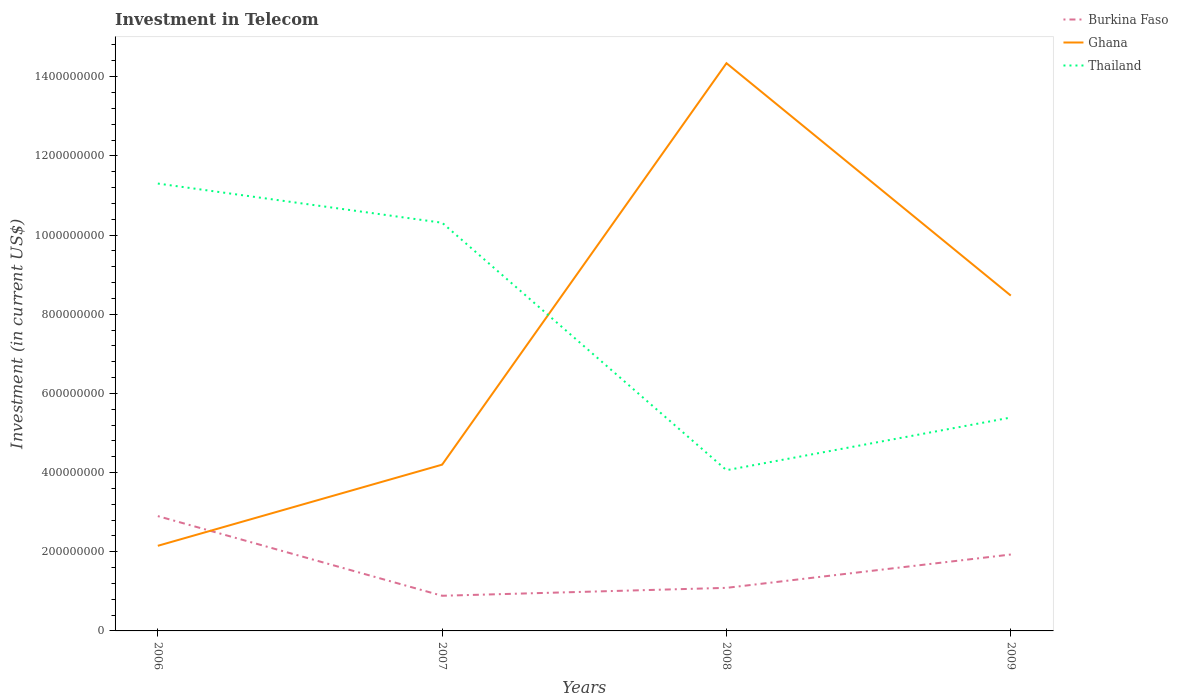How many different coloured lines are there?
Provide a succinct answer. 3. Across all years, what is the maximum amount invested in telecom in Burkina Faso?
Ensure brevity in your answer.  8.88e+07. What is the total amount invested in telecom in Ghana in the graph?
Your answer should be compact. -4.27e+08. What is the difference between the highest and the second highest amount invested in telecom in Ghana?
Keep it short and to the point. 1.22e+09. What is the difference between the highest and the lowest amount invested in telecom in Thailand?
Offer a terse response. 2. Is the amount invested in telecom in Burkina Faso strictly greater than the amount invested in telecom in Ghana over the years?
Give a very brief answer. No. How many lines are there?
Give a very brief answer. 3. What is the difference between two consecutive major ticks on the Y-axis?
Give a very brief answer. 2.00e+08. Are the values on the major ticks of Y-axis written in scientific E-notation?
Keep it short and to the point. No. Where does the legend appear in the graph?
Offer a very short reply. Top right. What is the title of the graph?
Keep it short and to the point. Investment in Telecom. What is the label or title of the Y-axis?
Your answer should be compact. Investment (in current US$). What is the Investment (in current US$) of Burkina Faso in 2006?
Your response must be concise. 2.90e+08. What is the Investment (in current US$) in Ghana in 2006?
Your answer should be very brief. 2.15e+08. What is the Investment (in current US$) in Thailand in 2006?
Offer a terse response. 1.13e+09. What is the Investment (in current US$) in Burkina Faso in 2007?
Make the answer very short. 8.88e+07. What is the Investment (in current US$) of Ghana in 2007?
Provide a succinct answer. 4.20e+08. What is the Investment (in current US$) of Thailand in 2007?
Your answer should be compact. 1.03e+09. What is the Investment (in current US$) in Burkina Faso in 2008?
Your response must be concise. 1.09e+08. What is the Investment (in current US$) in Ghana in 2008?
Provide a succinct answer. 1.43e+09. What is the Investment (in current US$) of Thailand in 2008?
Make the answer very short. 4.06e+08. What is the Investment (in current US$) of Burkina Faso in 2009?
Provide a succinct answer. 1.93e+08. What is the Investment (in current US$) in Ghana in 2009?
Provide a short and direct response. 8.47e+08. What is the Investment (in current US$) of Thailand in 2009?
Keep it short and to the point. 5.39e+08. Across all years, what is the maximum Investment (in current US$) in Burkina Faso?
Offer a terse response. 2.90e+08. Across all years, what is the maximum Investment (in current US$) in Ghana?
Provide a succinct answer. 1.43e+09. Across all years, what is the maximum Investment (in current US$) in Thailand?
Your response must be concise. 1.13e+09. Across all years, what is the minimum Investment (in current US$) in Burkina Faso?
Offer a very short reply. 8.88e+07. Across all years, what is the minimum Investment (in current US$) in Ghana?
Ensure brevity in your answer.  2.15e+08. Across all years, what is the minimum Investment (in current US$) in Thailand?
Your response must be concise. 4.06e+08. What is the total Investment (in current US$) of Burkina Faso in the graph?
Keep it short and to the point. 6.81e+08. What is the total Investment (in current US$) of Ghana in the graph?
Keep it short and to the point. 2.92e+09. What is the total Investment (in current US$) of Thailand in the graph?
Make the answer very short. 3.11e+09. What is the difference between the Investment (in current US$) of Burkina Faso in 2006 and that in 2007?
Offer a terse response. 2.01e+08. What is the difference between the Investment (in current US$) in Ghana in 2006 and that in 2007?
Your answer should be very brief. -2.05e+08. What is the difference between the Investment (in current US$) in Thailand in 2006 and that in 2007?
Make the answer very short. 9.90e+07. What is the difference between the Investment (in current US$) in Burkina Faso in 2006 and that in 2008?
Make the answer very short. 1.81e+08. What is the difference between the Investment (in current US$) in Ghana in 2006 and that in 2008?
Your answer should be compact. -1.22e+09. What is the difference between the Investment (in current US$) in Thailand in 2006 and that in 2008?
Your response must be concise. 7.24e+08. What is the difference between the Investment (in current US$) of Burkina Faso in 2006 and that in 2009?
Offer a terse response. 9.70e+07. What is the difference between the Investment (in current US$) of Ghana in 2006 and that in 2009?
Provide a short and direct response. -6.32e+08. What is the difference between the Investment (in current US$) of Thailand in 2006 and that in 2009?
Your answer should be very brief. 5.91e+08. What is the difference between the Investment (in current US$) in Burkina Faso in 2007 and that in 2008?
Your answer should be compact. -2.00e+07. What is the difference between the Investment (in current US$) in Ghana in 2007 and that in 2008?
Your answer should be compact. -1.01e+09. What is the difference between the Investment (in current US$) of Thailand in 2007 and that in 2008?
Your response must be concise. 6.25e+08. What is the difference between the Investment (in current US$) in Burkina Faso in 2007 and that in 2009?
Your answer should be very brief. -1.04e+08. What is the difference between the Investment (in current US$) in Ghana in 2007 and that in 2009?
Provide a short and direct response. -4.27e+08. What is the difference between the Investment (in current US$) in Thailand in 2007 and that in 2009?
Your answer should be very brief. 4.92e+08. What is the difference between the Investment (in current US$) in Burkina Faso in 2008 and that in 2009?
Give a very brief answer. -8.42e+07. What is the difference between the Investment (in current US$) in Ghana in 2008 and that in 2009?
Keep it short and to the point. 5.87e+08. What is the difference between the Investment (in current US$) of Thailand in 2008 and that in 2009?
Your answer should be compact. -1.33e+08. What is the difference between the Investment (in current US$) of Burkina Faso in 2006 and the Investment (in current US$) of Ghana in 2007?
Your answer should be very brief. -1.30e+08. What is the difference between the Investment (in current US$) in Burkina Faso in 2006 and the Investment (in current US$) in Thailand in 2007?
Provide a short and direct response. -7.41e+08. What is the difference between the Investment (in current US$) in Ghana in 2006 and the Investment (in current US$) in Thailand in 2007?
Offer a very short reply. -8.16e+08. What is the difference between the Investment (in current US$) in Burkina Faso in 2006 and the Investment (in current US$) in Ghana in 2008?
Provide a succinct answer. -1.14e+09. What is the difference between the Investment (in current US$) in Burkina Faso in 2006 and the Investment (in current US$) in Thailand in 2008?
Keep it short and to the point. -1.16e+08. What is the difference between the Investment (in current US$) of Ghana in 2006 and the Investment (in current US$) of Thailand in 2008?
Your answer should be very brief. -1.91e+08. What is the difference between the Investment (in current US$) in Burkina Faso in 2006 and the Investment (in current US$) in Ghana in 2009?
Your answer should be compact. -5.57e+08. What is the difference between the Investment (in current US$) in Burkina Faso in 2006 and the Investment (in current US$) in Thailand in 2009?
Keep it short and to the point. -2.49e+08. What is the difference between the Investment (in current US$) in Ghana in 2006 and the Investment (in current US$) in Thailand in 2009?
Ensure brevity in your answer.  -3.24e+08. What is the difference between the Investment (in current US$) of Burkina Faso in 2007 and the Investment (in current US$) of Ghana in 2008?
Your response must be concise. -1.35e+09. What is the difference between the Investment (in current US$) of Burkina Faso in 2007 and the Investment (in current US$) of Thailand in 2008?
Offer a terse response. -3.17e+08. What is the difference between the Investment (in current US$) of Ghana in 2007 and the Investment (in current US$) of Thailand in 2008?
Offer a very short reply. 1.40e+07. What is the difference between the Investment (in current US$) in Burkina Faso in 2007 and the Investment (in current US$) in Ghana in 2009?
Your answer should be very brief. -7.58e+08. What is the difference between the Investment (in current US$) of Burkina Faso in 2007 and the Investment (in current US$) of Thailand in 2009?
Provide a short and direct response. -4.50e+08. What is the difference between the Investment (in current US$) of Ghana in 2007 and the Investment (in current US$) of Thailand in 2009?
Offer a very short reply. -1.19e+08. What is the difference between the Investment (in current US$) of Burkina Faso in 2008 and the Investment (in current US$) of Ghana in 2009?
Offer a very short reply. -7.38e+08. What is the difference between the Investment (in current US$) of Burkina Faso in 2008 and the Investment (in current US$) of Thailand in 2009?
Make the answer very short. -4.30e+08. What is the difference between the Investment (in current US$) in Ghana in 2008 and the Investment (in current US$) in Thailand in 2009?
Keep it short and to the point. 8.95e+08. What is the average Investment (in current US$) in Burkina Faso per year?
Your response must be concise. 1.70e+08. What is the average Investment (in current US$) of Ghana per year?
Ensure brevity in your answer.  7.29e+08. What is the average Investment (in current US$) of Thailand per year?
Offer a terse response. 7.76e+08. In the year 2006, what is the difference between the Investment (in current US$) of Burkina Faso and Investment (in current US$) of Ghana?
Make the answer very short. 7.50e+07. In the year 2006, what is the difference between the Investment (in current US$) in Burkina Faso and Investment (in current US$) in Thailand?
Offer a terse response. -8.40e+08. In the year 2006, what is the difference between the Investment (in current US$) in Ghana and Investment (in current US$) in Thailand?
Offer a terse response. -9.15e+08. In the year 2007, what is the difference between the Investment (in current US$) of Burkina Faso and Investment (in current US$) of Ghana?
Your answer should be compact. -3.31e+08. In the year 2007, what is the difference between the Investment (in current US$) in Burkina Faso and Investment (in current US$) in Thailand?
Your response must be concise. -9.42e+08. In the year 2007, what is the difference between the Investment (in current US$) of Ghana and Investment (in current US$) of Thailand?
Offer a terse response. -6.11e+08. In the year 2008, what is the difference between the Investment (in current US$) of Burkina Faso and Investment (in current US$) of Ghana?
Make the answer very short. -1.33e+09. In the year 2008, what is the difference between the Investment (in current US$) in Burkina Faso and Investment (in current US$) in Thailand?
Your answer should be very brief. -2.97e+08. In the year 2008, what is the difference between the Investment (in current US$) in Ghana and Investment (in current US$) in Thailand?
Your answer should be very brief. 1.03e+09. In the year 2009, what is the difference between the Investment (in current US$) of Burkina Faso and Investment (in current US$) of Ghana?
Make the answer very short. -6.54e+08. In the year 2009, what is the difference between the Investment (in current US$) in Burkina Faso and Investment (in current US$) in Thailand?
Offer a terse response. -3.46e+08. In the year 2009, what is the difference between the Investment (in current US$) in Ghana and Investment (in current US$) in Thailand?
Offer a terse response. 3.08e+08. What is the ratio of the Investment (in current US$) of Burkina Faso in 2006 to that in 2007?
Ensure brevity in your answer.  3.27. What is the ratio of the Investment (in current US$) of Ghana in 2006 to that in 2007?
Keep it short and to the point. 0.51. What is the ratio of the Investment (in current US$) of Thailand in 2006 to that in 2007?
Provide a short and direct response. 1.1. What is the ratio of the Investment (in current US$) of Burkina Faso in 2006 to that in 2008?
Your response must be concise. 2.67. What is the ratio of the Investment (in current US$) of Ghana in 2006 to that in 2008?
Make the answer very short. 0.15. What is the ratio of the Investment (in current US$) of Thailand in 2006 to that in 2008?
Make the answer very short. 2.78. What is the ratio of the Investment (in current US$) in Burkina Faso in 2006 to that in 2009?
Make the answer very short. 1.5. What is the ratio of the Investment (in current US$) in Ghana in 2006 to that in 2009?
Provide a short and direct response. 0.25. What is the ratio of the Investment (in current US$) of Thailand in 2006 to that in 2009?
Offer a very short reply. 2.1. What is the ratio of the Investment (in current US$) in Burkina Faso in 2007 to that in 2008?
Offer a very short reply. 0.82. What is the ratio of the Investment (in current US$) of Ghana in 2007 to that in 2008?
Your answer should be very brief. 0.29. What is the ratio of the Investment (in current US$) of Thailand in 2007 to that in 2008?
Offer a terse response. 2.54. What is the ratio of the Investment (in current US$) of Burkina Faso in 2007 to that in 2009?
Your answer should be compact. 0.46. What is the ratio of the Investment (in current US$) of Ghana in 2007 to that in 2009?
Make the answer very short. 0.5. What is the ratio of the Investment (in current US$) in Thailand in 2007 to that in 2009?
Your response must be concise. 1.91. What is the ratio of the Investment (in current US$) of Burkina Faso in 2008 to that in 2009?
Offer a very short reply. 0.56. What is the ratio of the Investment (in current US$) of Ghana in 2008 to that in 2009?
Give a very brief answer. 1.69. What is the ratio of the Investment (in current US$) of Thailand in 2008 to that in 2009?
Give a very brief answer. 0.75. What is the difference between the highest and the second highest Investment (in current US$) of Burkina Faso?
Provide a succinct answer. 9.70e+07. What is the difference between the highest and the second highest Investment (in current US$) in Ghana?
Give a very brief answer. 5.87e+08. What is the difference between the highest and the second highest Investment (in current US$) in Thailand?
Give a very brief answer. 9.90e+07. What is the difference between the highest and the lowest Investment (in current US$) of Burkina Faso?
Keep it short and to the point. 2.01e+08. What is the difference between the highest and the lowest Investment (in current US$) in Ghana?
Your answer should be compact. 1.22e+09. What is the difference between the highest and the lowest Investment (in current US$) of Thailand?
Give a very brief answer. 7.24e+08. 